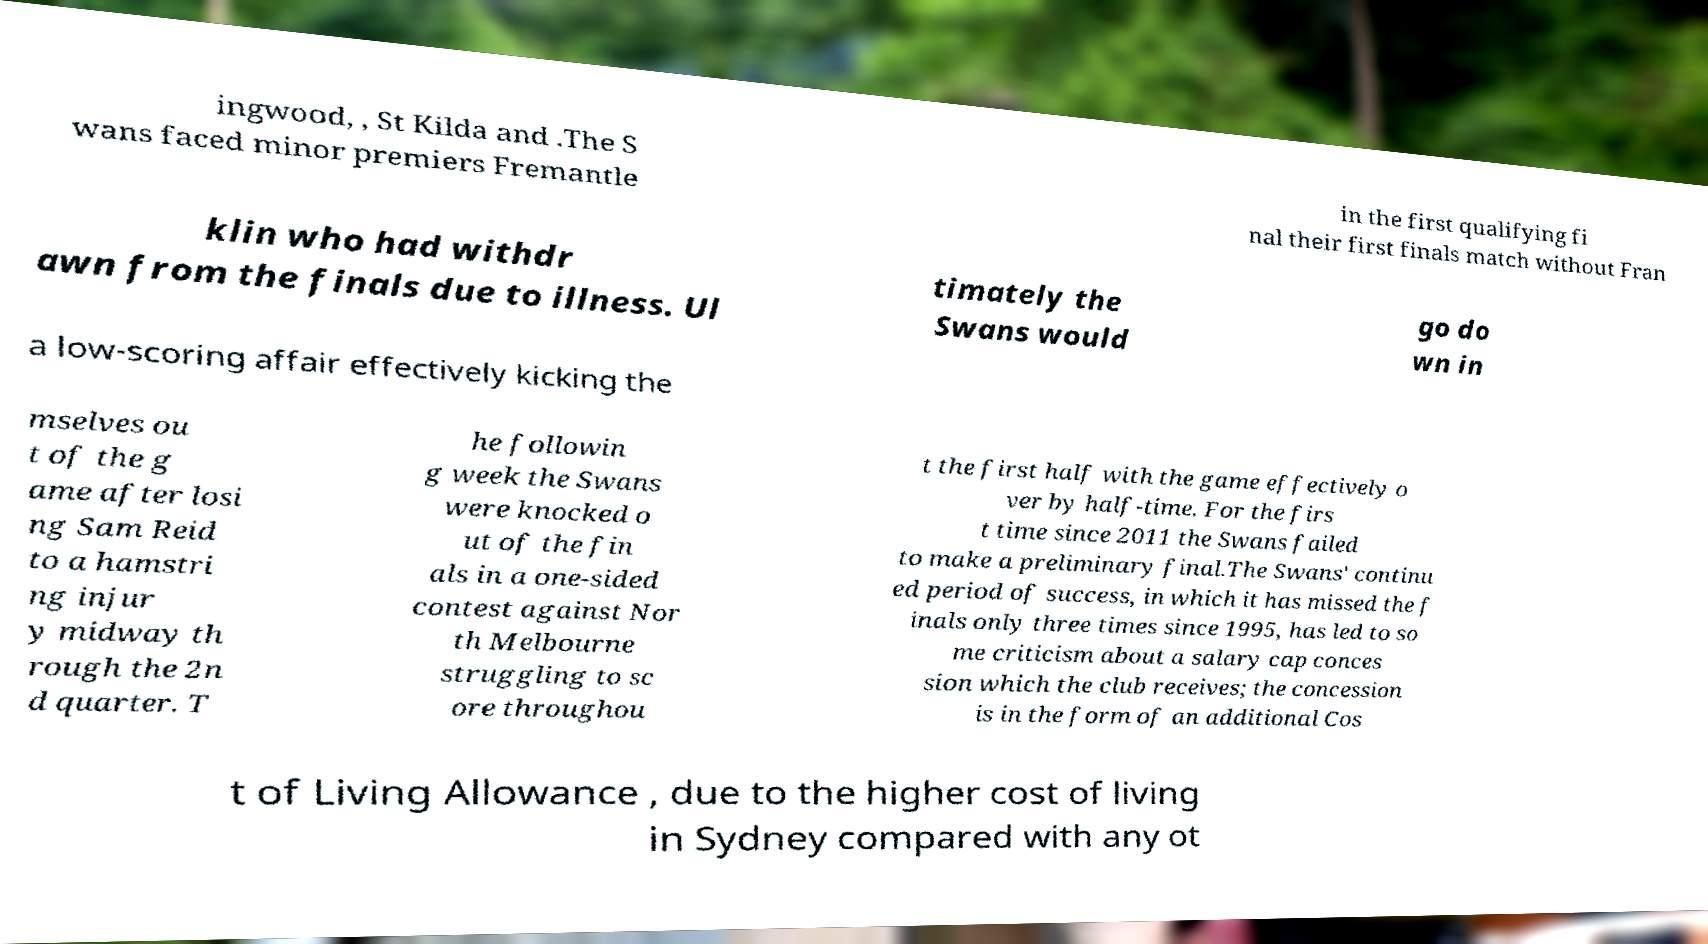Can you read and provide the text displayed in the image?This photo seems to have some interesting text. Can you extract and type it out for me? ingwood, , St Kilda and .The S wans faced minor premiers Fremantle in the first qualifying fi nal their first finals match without Fran klin who had withdr awn from the finals due to illness. Ul timately the Swans would go do wn in a low-scoring affair effectively kicking the mselves ou t of the g ame after losi ng Sam Reid to a hamstri ng injur y midway th rough the 2n d quarter. T he followin g week the Swans were knocked o ut of the fin als in a one-sided contest against Nor th Melbourne struggling to sc ore throughou t the first half with the game effectively o ver by half-time. For the firs t time since 2011 the Swans failed to make a preliminary final.The Swans' continu ed period of success, in which it has missed the f inals only three times since 1995, has led to so me criticism about a salary cap conces sion which the club receives; the concession is in the form of an additional Cos t of Living Allowance , due to the higher cost of living in Sydney compared with any ot 